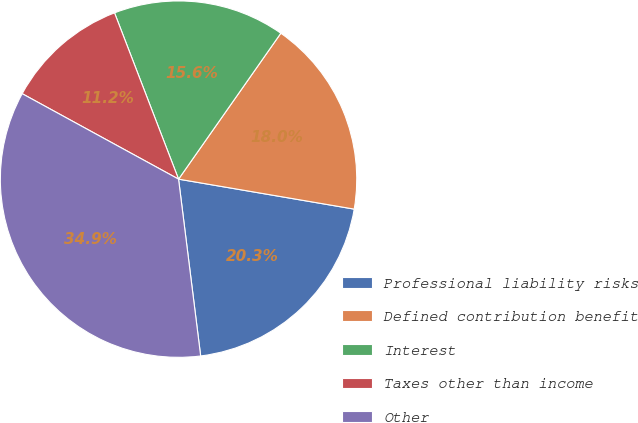Convert chart to OTSL. <chart><loc_0><loc_0><loc_500><loc_500><pie_chart><fcel>Professional liability risks<fcel>Defined contribution benefit<fcel>Interest<fcel>Taxes other than income<fcel>Other<nl><fcel>20.33%<fcel>17.96%<fcel>15.58%<fcel>11.19%<fcel>34.94%<nl></chart> 